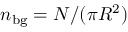Convert formula to latex. <formula><loc_0><loc_0><loc_500><loc_500>n _ { b g } = N / ( \pi R ^ { 2 } )</formula> 